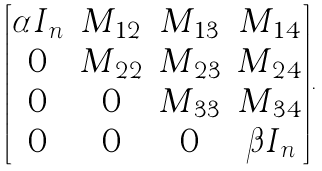Convert formula to latex. <formula><loc_0><loc_0><loc_500><loc_500>\begin{bmatrix} \alpha I _ { n } & M _ { 1 2 } & M _ { 1 3 } & M _ { 1 4 } \\ 0 & M _ { 2 2 } & M _ { 2 3 } & M _ { 2 4 } \\ 0 & 0 & M _ { 3 3 } & M _ { 3 4 } \\ 0 & 0 & 0 & \beta I _ { n } \end{bmatrix} .</formula> 